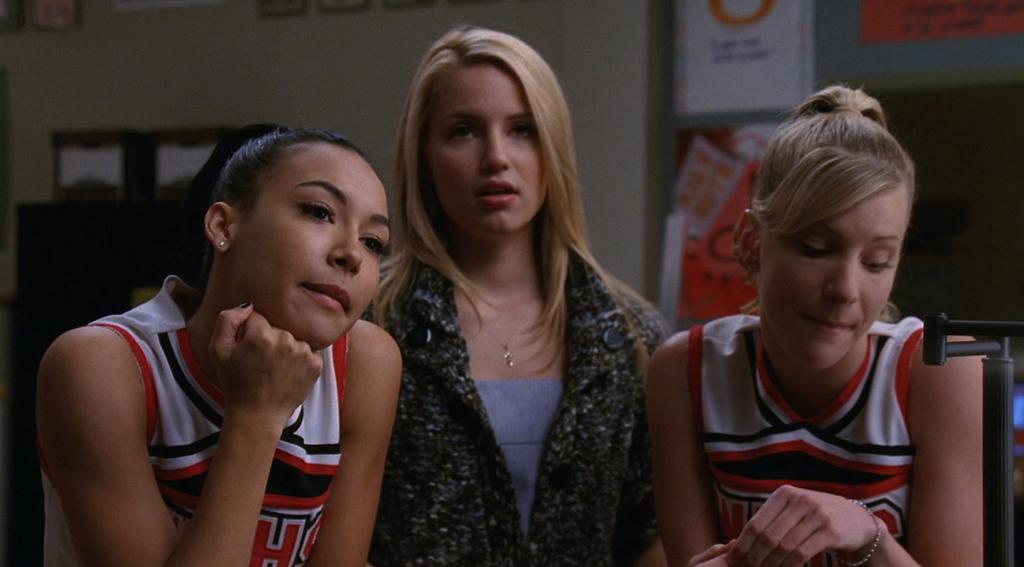What letter is visible on the cheerleading jersey?
Your response must be concise. H. 